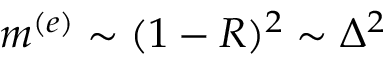Convert formula to latex. <formula><loc_0><loc_0><loc_500><loc_500>m ^ { ( e ) } \sim ( 1 - R ) ^ { 2 } \sim \Delta ^ { 2 }</formula> 